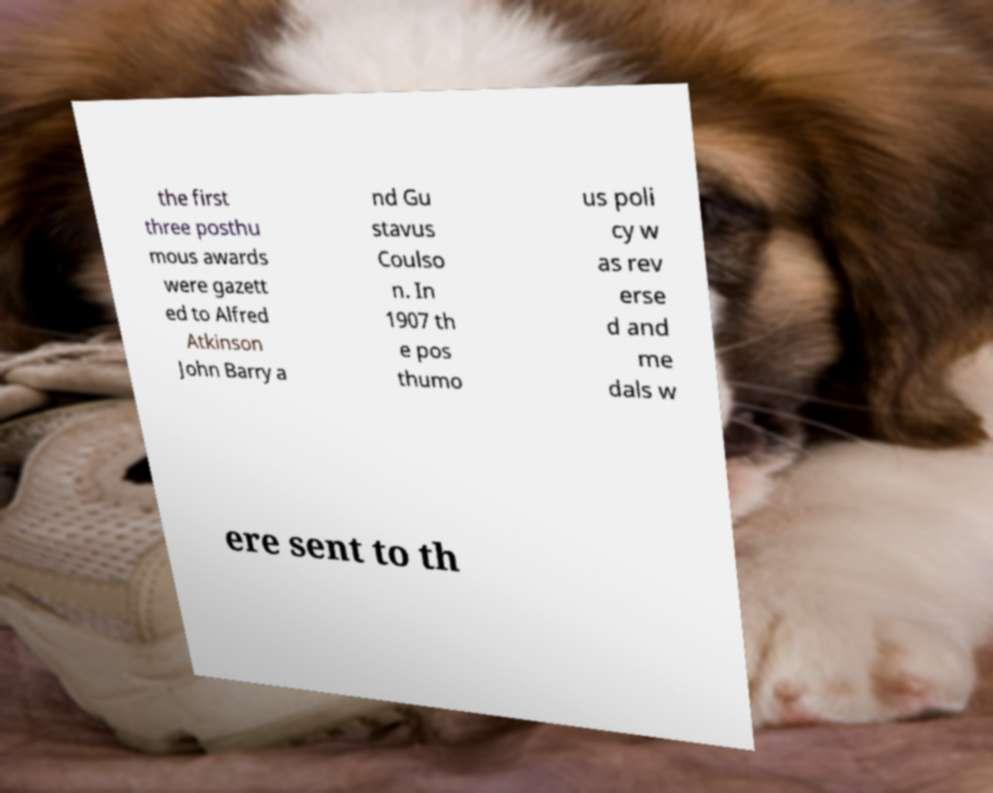Could you extract and type out the text from this image? the first three posthu mous awards were gazett ed to Alfred Atkinson John Barry a nd Gu stavus Coulso n. In 1907 th e pos thumo us poli cy w as rev erse d and me dals w ere sent to th 